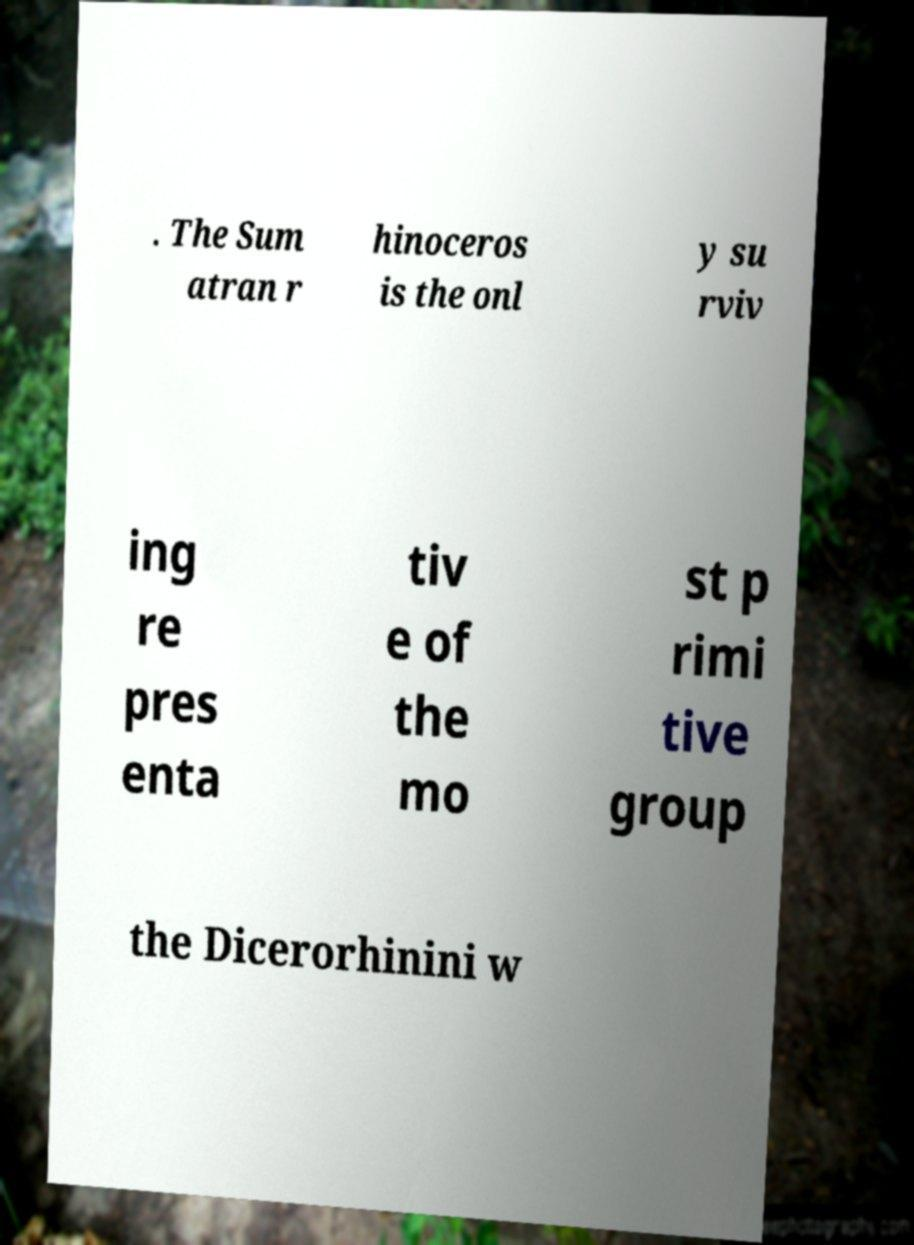Please identify and transcribe the text found in this image. . The Sum atran r hinoceros is the onl y su rviv ing re pres enta tiv e of the mo st p rimi tive group the Dicerorhinini w 